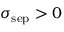<formula> <loc_0><loc_0><loc_500><loc_500>\sigma _ { s e p } > 0</formula> 